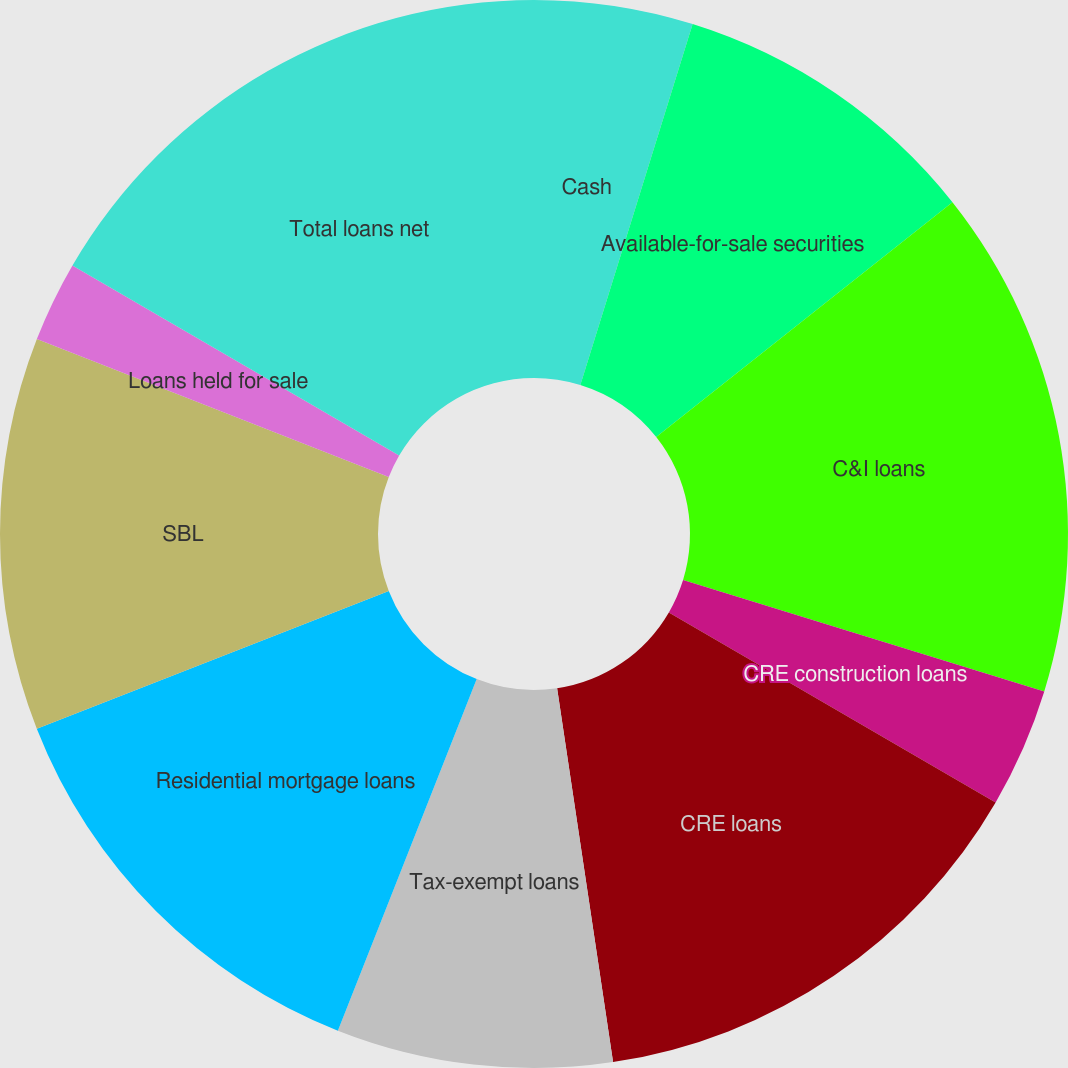Convert chart. <chart><loc_0><loc_0><loc_500><loc_500><pie_chart><fcel>Cash<fcel>Available-for-sale securities<fcel>C&I loans<fcel>CRE construction loans<fcel>CRE loans<fcel>Tax-exempt loans<fcel>Residential mortgage loans<fcel>SBL<fcel>Loans held for sale<fcel>Total loans net<nl><fcel>4.8%<fcel>9.53%<fcel>15.43%<fcel>3.62%<fcel>14.25%<fcel>8.35%<fcel>13.07%<fcel>11.89%<fcel>2.44%<fcel>16.61%<nl></chart> 